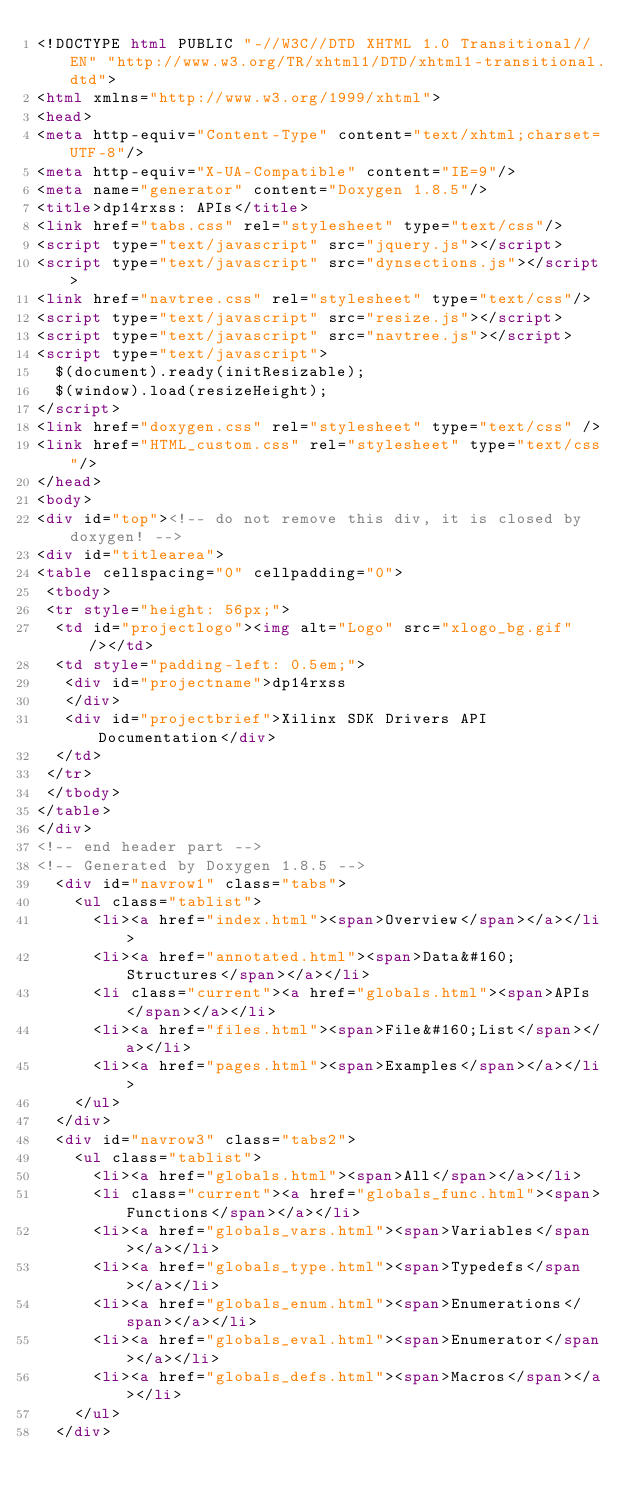Convert code to text. <code><loc_0><loc_0><loc_500><loc_500><_HTML_><!DOCTYPE html PUBLIC "-//W3C//DTD XHTML 1.0 Transitional//EN" "http://www.w3.org/TR/xhtml1/DTD/xhtml1-transitional.dtd">
<html xmlns="http://www.w3.org/1999/xhtml">
<head>
<meta http-equiv="Content-Type" content="text/xhtml;charset=UTF-8"/>
<meta http-equiv="X-UA-Compatible" content="IE=9"/>
<meta name="generator" content="Doxygen 1.8.5"/>
<title>dp14rxss: APIs</title>
<link href="tabs.css" rel="stylesheet" type="text/css"/>
<script type="text/javascript" src="jquery.js"></script>
<script type="text/javascript" src="dynsections.js"></script>
<link href="navtree.css" rel="stylesheet" type="text/css"/>
<script type="text/javascript" src="resize.js"></script>
<script type="text/javascript" src="navtree.js"></script>
<script type="text/javascript">
  $(document).ready(initResizable);
  $(window).load(resizeHeight);
</script>
<link href="doxygen.css" rel="stylesheet" type="text/css" />
<link href="HTML_custom.css" rel="stylesheet" type="text/css"/>
</head>
<body>
<div id="top"><!-- do not remove this div, it is closed by doxygen! -->
<div id="titlearea">
<table cellspacing="0" cellpadding="0">
 <tbody>
 <tr style="height: 56px;">
  <td id="projectlogo"><img alt="Logo" src="xlogo_bg.gif"/></td>
  <td style="padding-left: 0.5em;">
   <div id="projectname">dp14rxss
   </div>
   <div id="projectbrief">Xilinx SDK Drivers API Documentation</div>
  </td>
 </tr>
 </tbody>
</table>
</div>
<!-- end header part -->
<!-- Generated by Doxygen 1.8.5 -->
  <div id="navrow1" class="tabs">
    <ul class="tablist">
      <li><a href="index.html"><span>Overview</span></a></li>
      <li><a href="annotated.html"><span>Data&#160;Structures</span></a></li>
      <li class="current"><a href="globals.html"><span>APIs</span></a></li>
      <li><a href="files.html"><span>File&#160;List</span></a></li>
      <li><a href="pages.html"><span>Examples</span></a></li>
    </ul>
  </div>
  <div id="navrow3" class="tabs2">
    <ul class="tablist">
      <li><a href="globals.html"><span>All</span></a></li>
      <li class="current"><a href="globals_func.html"><span>Functions</span></a></li>
      <li><a href="globals_vars.html"><span>Variables</span></a></li>
      <li><a href="globals_type.html"><span>Typedefs</span></a></li>
      <li><a href="globals_enum.html"><span>Enumerations</span></a></li>
      <li><a href="globals_eval.html"><span>Enumerator</span></a></li>
      <li><a href="globals_defs.html"><span>Macros</span></a></li>
    </ul>
  </div></code> 